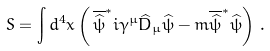<formula> <loc_0><loc_0><loc_500><loc_500>S = \int d ^ { 4 } x \left ( \, \overline { \widehat { \psi } } ^ { * } i \gamma ^ { \mu } \widehat { D } _ { \mu } \widehat { \psi } - m \overline { \widehat { \psi } } ^ { * } \widehat { \psi } \right ) \, .</formula> 